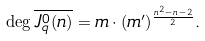Convert formula to latex. <formula><loc_0><loc_0><loc_500><loc_500>\deg \overline { J ^ { 0 } _ { q } ( n ) } = m \cdot ( m ^ { \prime } ) ^ { \frac { n ^ { 2 } - n - 2 } { 2 } } .</formula> 